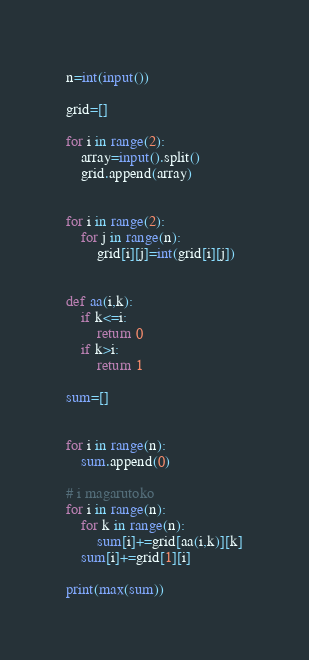<code> <loc_0><loc_0><loc_500><loc_500><_Python_>n=int(input())

grid=[]

for i in range(2):
    array=input().split()
    grid.append(array)


for i in range(2):
    for j in range(n):
        grid[i][j]=int(grid[i][j])


def aa(i,k):
    if k<=i:
        return 0
    if k>i:
        return 1

sum=[]


for i in range(n):
    sum.append(0)

# i magarutoko
for i in range(n):
    for k in range(n):
        sum[i]+=grid[aa(i,k)][k]
    sum[i]+=grid[1][i]

print(max(sum))

</code> 